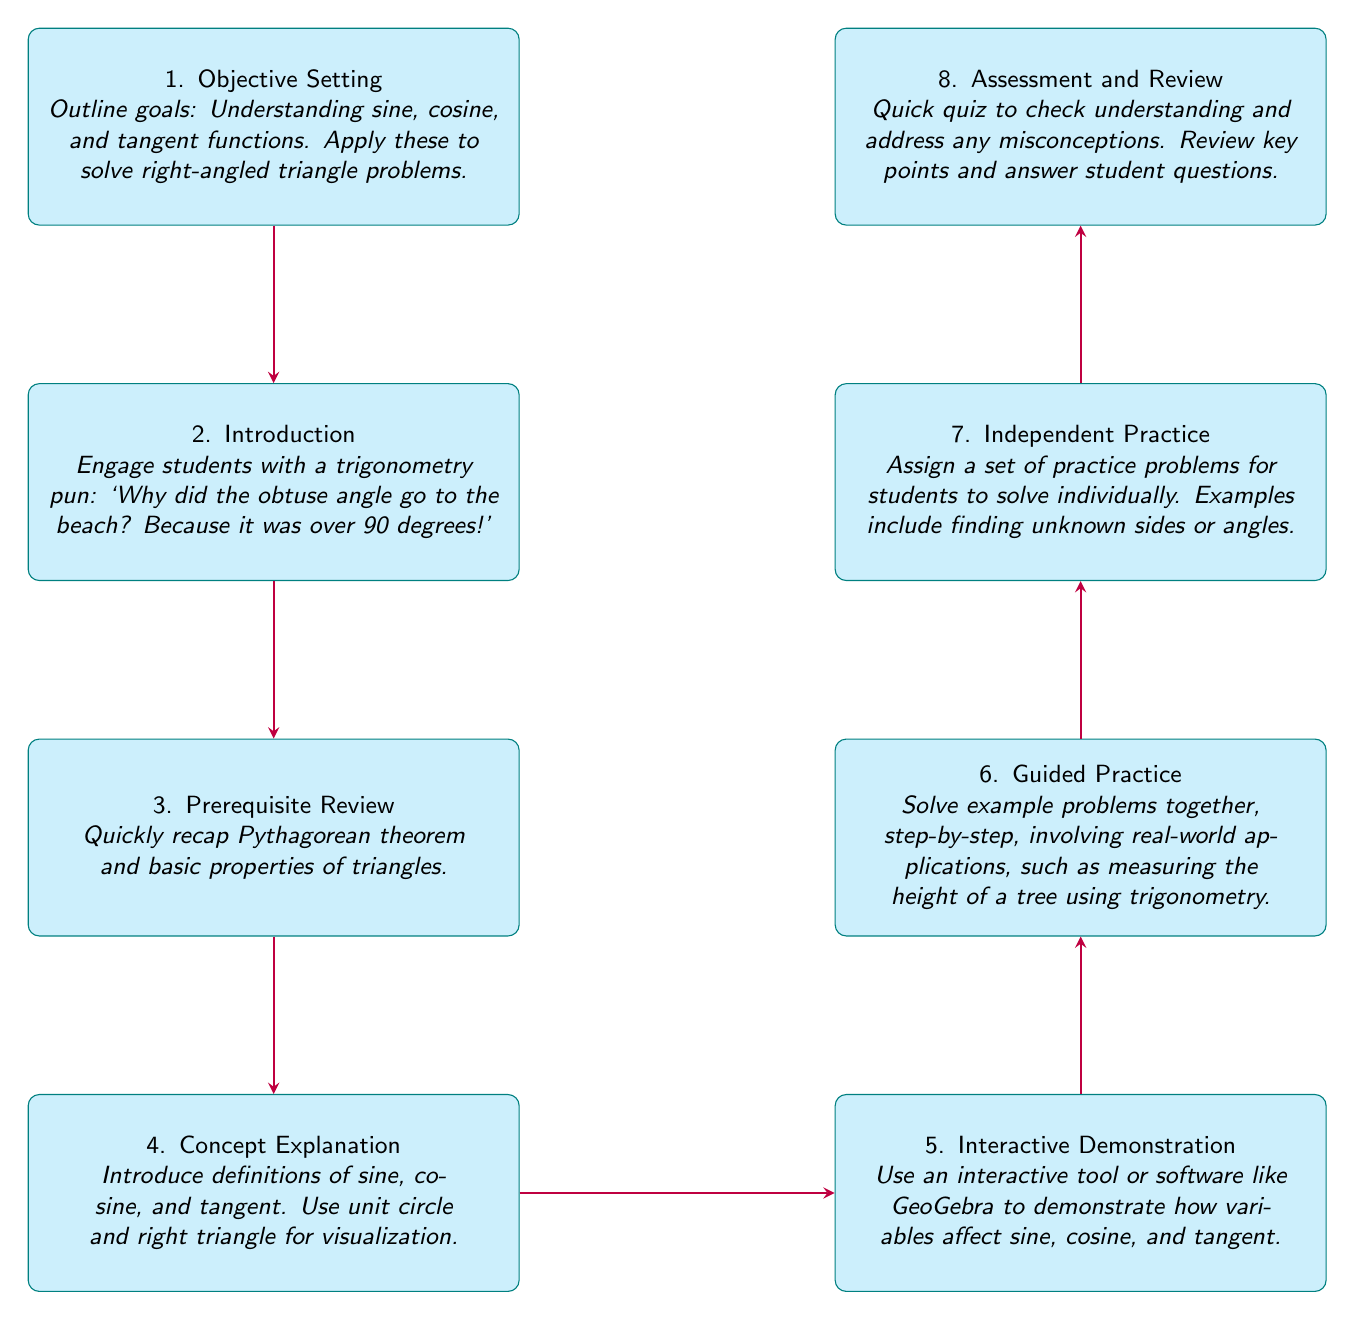What is the last step in the flow chart? The last step in the flow chart is labeled "Assessment and Review." It is connected from the previous node "Independent Practice."
Answer: Assessment and Review How many nodes are in the flow chart? The flow chart contains a total of eight nodes, each representing a different step in the lesson planning process.
Answer: Eight What is the content of the second node? The second node is titled "Introduction," and its content is an engaging trigonometry pun that states: "Why did the obtuse angle go to the beach? Because it was over 90 degrees!"
Answer: Engage students with a trigonometry pun: "Why did the obtuse angle go to the beach? Because it was over 90 degrees!" Which node follows "Guided Practice"? The node that follows "Guided Practice" is "Independent Practice." This indicates the next phase of the lesson after guided support.
Answer: Independent Practice Explain the relationship between "Concept Explanation" and "Interactive Demonstration." "Concept Explanation" comes before "Interactive Demonstration" in the flow chart. This shows that the concepts must be introduced and explained first before engaging students with the interactive demonstration using tools like GeoGebra.
Answer: Concept Explanation leads to Interactive Demonstration What is the purpose of the "Assessment and Review" node? The purpose of "Assessment and Review" is to check student understanding through a quiz and to address any misconceptions, as well as to review key points and answer questions.
Answer: Quick quiz to check understanding and address any misconceptions What type of practice is conducted after "Guided Practice"? After "Guided Practice," there is "Independent Practice," indicating that students will work on problems individually to reinforce their understanding of the concepts learned.
Answer: Independent Practice Name the content involved in the fourth node. The fourth node, titled "Concept Explanation," includes introducing definitions of sine, cosine, and tangent while using the unit circle and right triangle for visualization.
Answer: Introduce definitions of sine, cosine, and tangent. Use unit circle and right triangle for visualization Which node focuses on setting lesson objectives? The first node, "Objective Setting," is focused on outlining lesson goals such as understanding sine, cosine, and tangent functions.
Answer: Objective Setting 